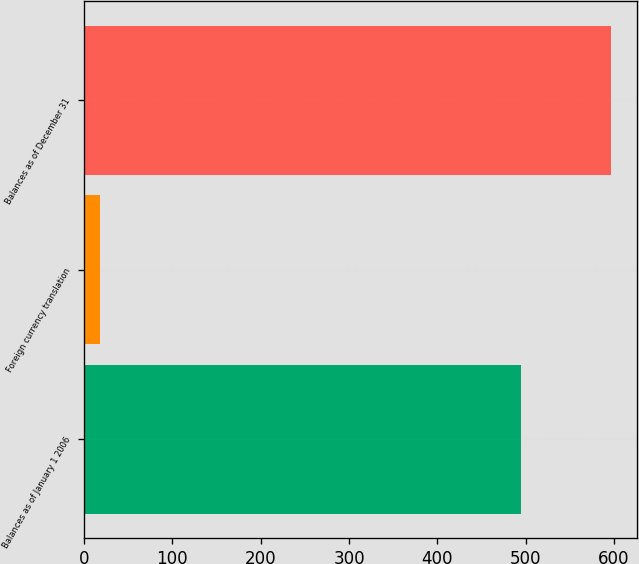Convert chart. <chart><loc_0><loc_0><loc_500><loc_500><bar_chart><fcel>Balances as of January 1 2006<fcel>Foreign currency translation<fcel>Balances as of December 31<nl><fcel>494.3<fcel>18.2<fcel>596.14<nl></chart> 